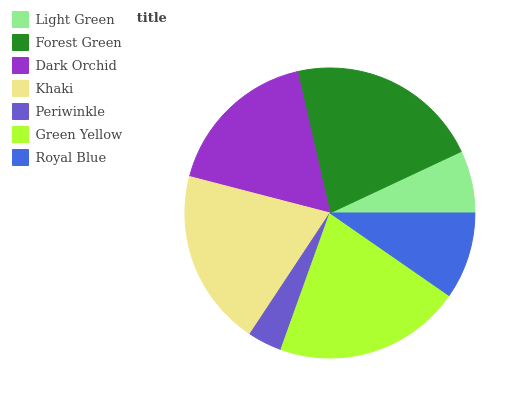Is Periwinkle the minimum?
Answer yes or no. Yes. Is Forest Green the maximum?
Answer yes or no. Yes. Is Dark Orchid the minimum?
Answer yes or no. No. Is Dark Orchid the maximum?
Answer yes or no. No. Is Forest Green greater than Dark Orchid?
Answer yes or no. Yes. Is Dark Orchid less than Forest Green?
Answer yes or no. Yes. Is Dark Orchid greater than Forest Green?
Answer yes or no. No. Is Forest Green less than Dark Orchid?
Answer yes or no. No. Is Dark Orchid the high median?
Answer yes or no. Yes. Is Dark Orchid the low median?
Answer yes or no. Yes. Is Royal Blue the high median?
Answer yes or no. No. Is Khaki the low median?
Answer yes or no. No. 